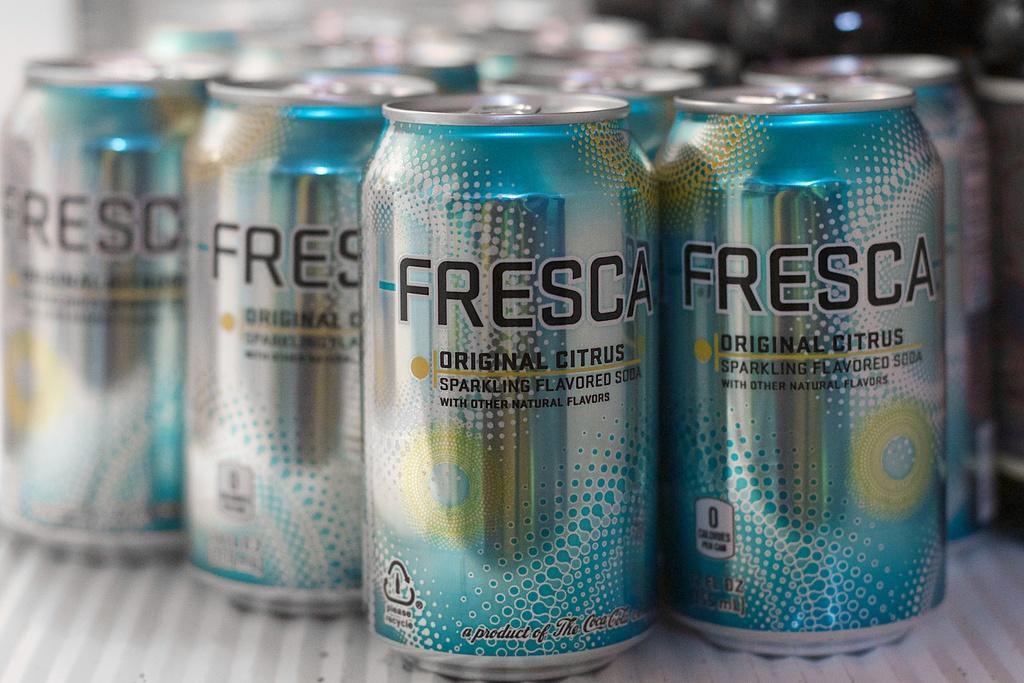Provide a one-sentence caption for the provided image. Many cans of Fresca soda sitting on a white shelf. 